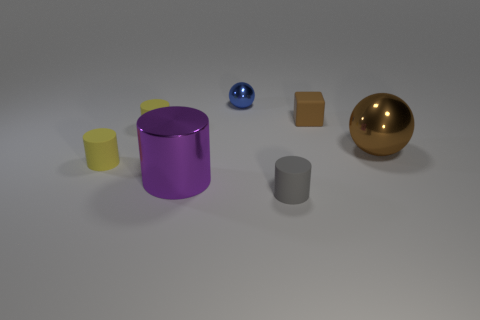Subtract all small gray cylinders. How many cylinders are left? 3 Subtract 1 cylinders. How many cylinders are left? 3 Subtract all gray blocks. How many yellow cylinders are left? 2 Add 3 small brown things. How many objects exist? 10 Subtract all gray cylinders. How many cylinders are left? 3 Subtract all green cylinders. Subtract all cyan spheres. How many cylinders are left? 4 Subtract all cylinders. How many objects are left? 3 Subtract 1 blue spheres. How many objects are left? 6 Subtract all tiny gray rubber things. Subtract all large cylinders. How many objects are left? 5 Add 4 small shiny objects. How many small shiny objects are left? 5 